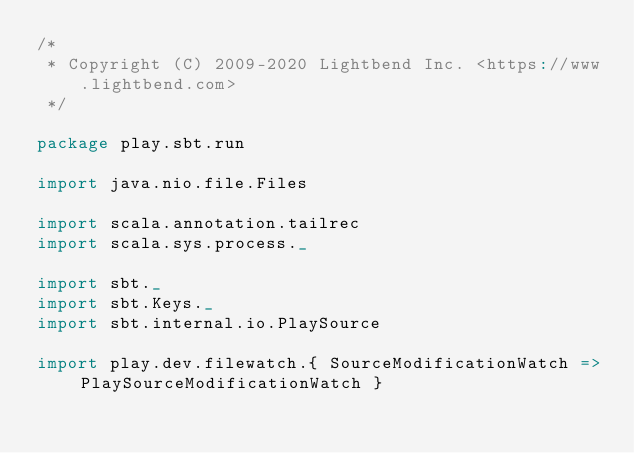<code> <loc_0><loc_0><loc_500><loc_500><_Scala_>/*
 * Copyright (C) 2009-2020 Lightbend Inc. <https://www.lightbend.com>
 */

package play.sbt.run

import java.nio.file.Files

import scala.annotation.tailrec
import scala.sys.process._

import sbt._
import sbt.Keys._
import sbt.internal.io.PlaySource

import play.dev.filewatch.{ SourceModificationWatch => PlaySourceModificationWatch }</code> 